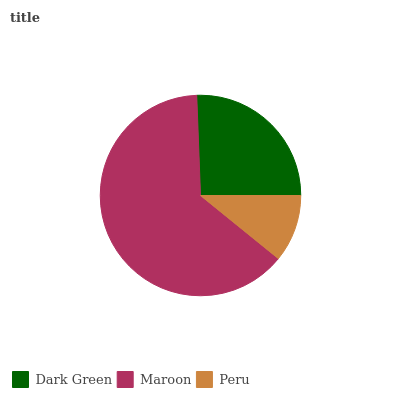Is Peru the minimum?
Answer yes or no. Yes. Is Maroon the maximum?
Answer yes or no. Yes. Is Maroon the minimum?
Answer yes or no. No. Is Peru the maximum?
Answer yes or no. No. Is Maroon greater than Peru?
Answer yes or no. Yes. Is Peru less than Maroon?
Answer yes or no. Yes. Is Peru greater than Maroon?
Answer yes or no. No. Is Maroon less than Peru?
Answer yes or no. No. Is Dark Green the high median?
Answer yes or no. Yes. Is Dark Green the low median?
Answer yes or no. Yes. Is Maroon the high median?
Answer yes or no. No. Is Peru the low median?
Answer yes or no. No. 